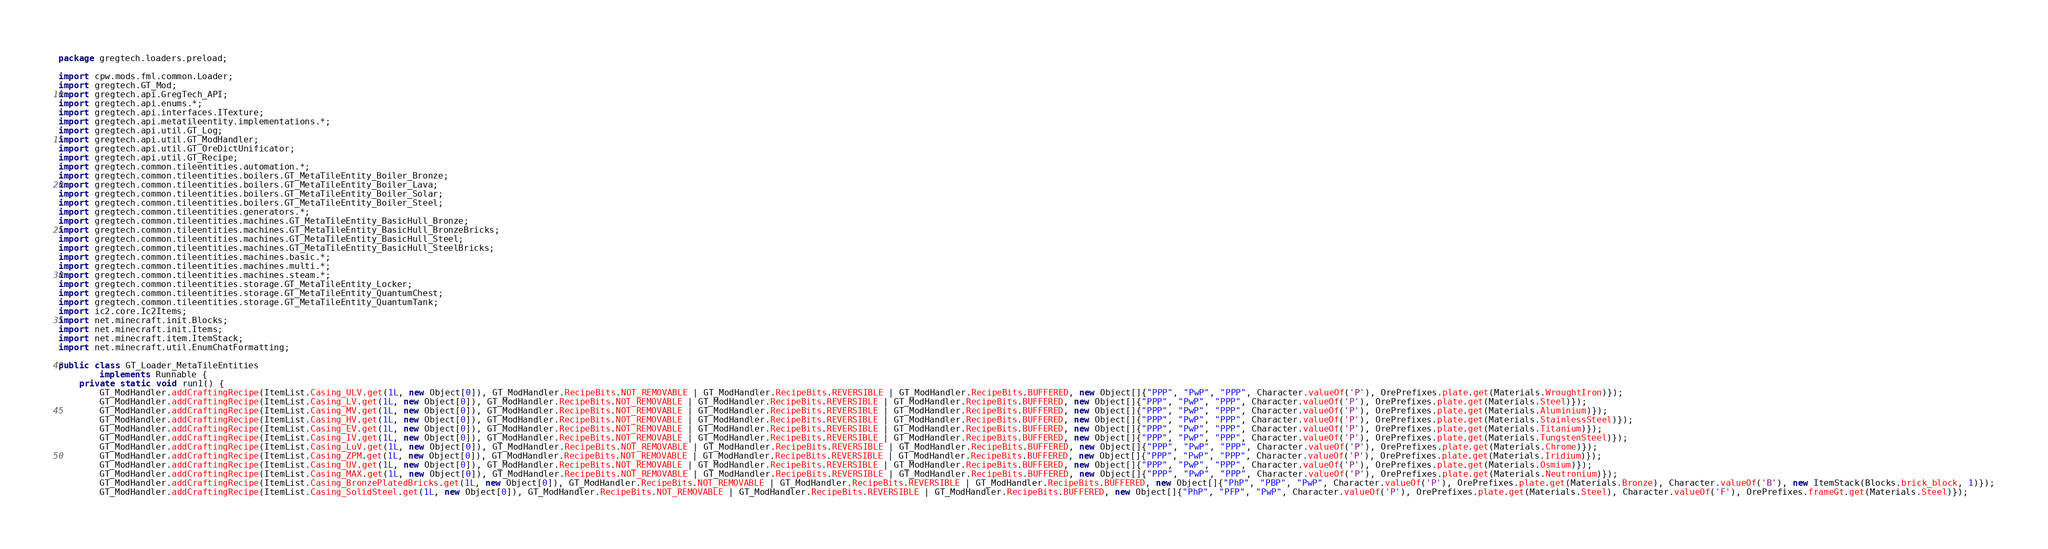<code> <loc_0><loc_0><loc_500><loc_500><_Java_>package gregtech.loaders.preload;

import cpw.mods.fml.common.Loader;
import gregtech.GT_Mod;
import gregtech.api.GregTech_API;
import gregtech.api.enums.*;
import gregtech.api.interfaces.ITexture;
import gregtech.api.metatileentity.implementations.*;
import gregtech.api.util.GT_Log;
import gregtech.api.util.GT_ModHandler;
import gregtech.api.util.GT_OreDictUnificator;
import gregtech.api.util.GT_Recipe;
import gregtech.common.tileentities.automation.*;
import gregtech.common.tileentities.boilers.GT_MetaTileEntity_Boiler_Bronze;
import gregtech.common.tileentities.boilers.GT_MetaTileEntity_Boiler_Lava;
import gregtech.common.tileentities.boilers.GT_MetaTileEntity_Boiler_Solar;
import gregtech.common.tileentities.boilers.GT_MetaTileEntity_Boiler_Steel;
import gregtech.common.tileentities.generators.*;
import gregtech.common.tileentities.machines.GT_MetaTileEntity_BasicHull_Bronze;
import gregtech.common.tileentities.machines.GT_MetaTileEntity_BasicHull_BronzeBricks;
import gregtech.common.tileentities.machines.GT_MetaTileEntity_BasicHull_Steel;
import gregtech.common.tileentities.machines.GT_MetaTileEntity_BasicHull_SteelBricks;
import gregtech.common.tileentities.machines.basic.*;
import gregtech.common.tileentities.machines.multi.*;
import gregtech.common.tileentities.machines.steam.*;
import gregtech.common.tileentities.storage.GT_MetaTileEntity_Locker;
import gregtech.common.tileentities.storage.GT_MetaTileEntity_QuantumChest;
import gregtech.common.tileentities.storage.GT_MetaTileEntity_QuantumTank;
import ic2.core.Ic2Items;
import net.minecraft.init.Blocks;
import net.minecraft.init.Items;
import net.minecraft.item.ItemStack;
import net.minecraft.util.EnumChatFormatting;

public class GT_Loader_MetaTileEntities
        implements Runnable {
    private static void run1() {
        GT_ModHandler.addCraftingRecipe(ItemList.Casing_ULV.get(1L, new Object[0]), GT_ModHandler.RecipeBits.NOT_REMOVABLE | GT_ModHandler.RecipeBits.REVERSIBLE | GT_ModHandler.RecipeBits.BUFFERED, new Object[]{"PPP", "PwP", "PPP", Character.valueOf('P'), OrePrefixes.plate.get(Materials.WroughtIron)});
        GT_ModHandler.addCraftingRecipe(ItemList.Casing_LV.get(1L, new Object[0]), GT_ModHandler.RecipeBits.NOT_REMOVABLE | GT_ModHandler.RecipeBits.REVERSIBLE | GT_ModHandler.RecipeBits.BUFFERED, new Object[]{"PPP", "PwP", "PPP", Character.valueOf('P'), OrePrefixes.plate.get(Materials.Steel)});
        GT_ModHandler.addCraftingRecipe(ItemList.Casing_MV.get(1L, new Object[0]), GT_ModHandler.RecipeBits.NOT_REMOVABLE | GT_ModHandler.RecipeBits.REVERSIBLE | GT_ModHandler.RecipeBits.BUFFERED, new Object[]{"PPP", "PwP", "PPP", Character.valueOf('P'), OrePrefixes.plate.get(Materials.Aluminium)});
        GT_ModHandler.addCraftingRecipe(ItemList.Casing_HV.get(1L, new Object[0]), GT_ModHandler.RecipeBits.NOT_REMOVABLE | GT_ModHandler.RecipeBits.REVERSIBLE | GT_ModHandler.RecipeBits.BUFFERED, new Object[]{"PPP", "PwP", "PPP", Character.valueOf('P'), OrePrefixes.plate.get(Materials.StainlessSteel)});
        GT_ModHandler.addCraftingRecipe(ItemList.Casing_EV.get(1L, new Object[0]), GT_ModHandler.RecipeBits.NOT_REMOVABLE | GT_ModHandler.RecipeBits.REVERSIBLE | GT_ModHandler.RecipeBits.BUFFERED, new Object[]{"PPP", "PwP", "PPP", Character.valueOf('P'), OrePrefixes.plate.get(Materials.Titanium)});
        GT_ModHandler.addCraftingRecipe(ItemList.Casing_IV.get(1L, new Object[0]), GT_ModHandler.RecipeBits.NOT_REMOVABLE | GT_ModHandler.RecipeBits.REVERSIBLE | GT_ModHandler.RecipeBits.BUFFERED, new Object[]{"PPP", "PwP", "PPP", Character.valueOf('P'), OrePrefixes.plate.get(Materials.TungstenSteel)});
        GT_ModHandler.addCraftingRecipe(ItemList.Casing_LuV.get(1L, new Object[0]), GT_ModHandler.RecipeBits.NOT_REMOVABLE | GT_ModHandler.RecipeBits.REVERSIBLE | GT_ModHandler.RecipeBits.BUFFERED, new Object[]{"PPP", "PwP", "PPP", Character.valueOf('P'), OrePrefixes.plate.get(Materials.Chrome)});
        GT_ModHandler.addCraftingRecipe(ItemList.Casing_ZPM.get(1L, new Object[0]), GT_ModHandler.RecipeBits.NOT_REMOVABLE | GT_ModHandler.RecipeBits.REVERSIBLE | GT_ModHandler.RecipeBits.BUFFERED, new Object[]{"PPP", "PwP", "PPP", Character.valueOf('P'), OrePrefixes.plate.get(Materials.Iridium)});
        GT_ModHandler.addCraftingRecipe(ItemList.Casing_UV.get(1L, new Object[0]), GT_ModHandler.RecipeBits.NOT_REMOVABLE | GT_ModHandler.RecipeBits.REVERSIBLE | GT_ModHandler.RecipeBits.BUFFERED, new Object[]{"PPP", "PwP", "PPP", Character.valueOf('P'), OrePrefixes.plate.get(Materials.Osmium)});
        GT_ModHandler.addCraftingRecipe(ItemList.Casing_MAX.get(1L, new Object[0]), GT_ModHandler.RecipeBits.NOT_REMOVABLE | GT_ModHandler.RecipeBits.REVERSIBLE | GT_ModHandler.RecipeBits.BUFFERED, new Object[]{"PPP", "PwP", "PPP", Character.valueOf('P'), OrePrefixes.plate.get(Materials.Neutronium)});
        GT_ModHandler.addCraftingRecipe(ItemList.Casing_BronzePlatedBricks.get(1L, new Object[0]), GT_ModHandler.RecipeBits.NOT_REMOVABLE | GT_ModHandler.RecipeBits.REVERSIBLE | GT_ModHandler.RecipeBits.BUFFERED, new Object[]{"PhP", "PBP", "PwP", Character.valueOf('P'), OrePrefixes.plate.get(Materials.Bronze), Character.valueOf('B'), new ItemStack(Blocks.brick_block, 1)});
        GT_ModHandler.addCraftingRecipe(ItemList.Casing_SolidSteel.get(1L, new Object[0]), GT_ModHandler.RecipeBits.NOT_REMOVABLE | GT_ModHandler.RecipeBits.REVERSIBLE | GT_ModHandler.RecipeBits.BUFFERED, new Object[]{"PhP", "PFP", "PwP", Character.valueOf('P'), OrePrefixes.plate.get(Materials.Steel), Character.valueOf('F'), OrePrefixes.frameGt.get(Materials.Steel)});</code> 